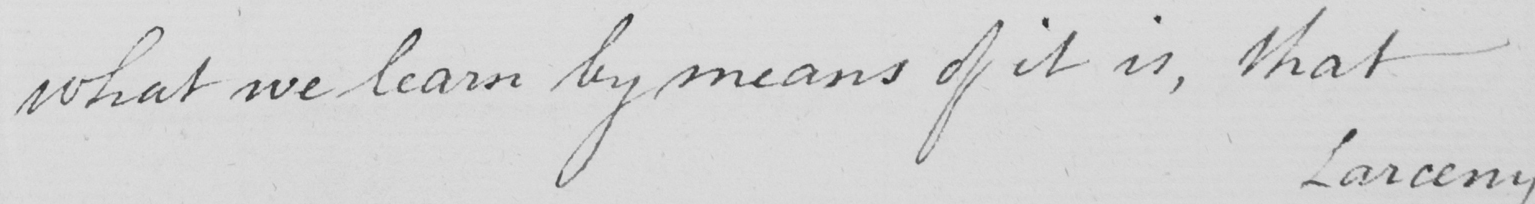Can you read and transcribe this handwriting? what we learn by means of it is , that 